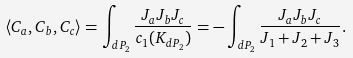<formula> <loc_0><loc_0><loc_500><loc_500>\langle C _ { a } , C _ { b } , C _ { c } \rangle = \int _ { d P _ { 2 } } \frac { J _ { a } J _ { b } J _ { c } } { c _ { 1 } ( K _ { d P _ { 2 } } ) } = - \int _ { d P _ { 2 } } \frac { J _ { a } J _ { b } J _ { c } } { J _ { 1 } + J _ { 2 } + J _ { 3 } } .</formula> 